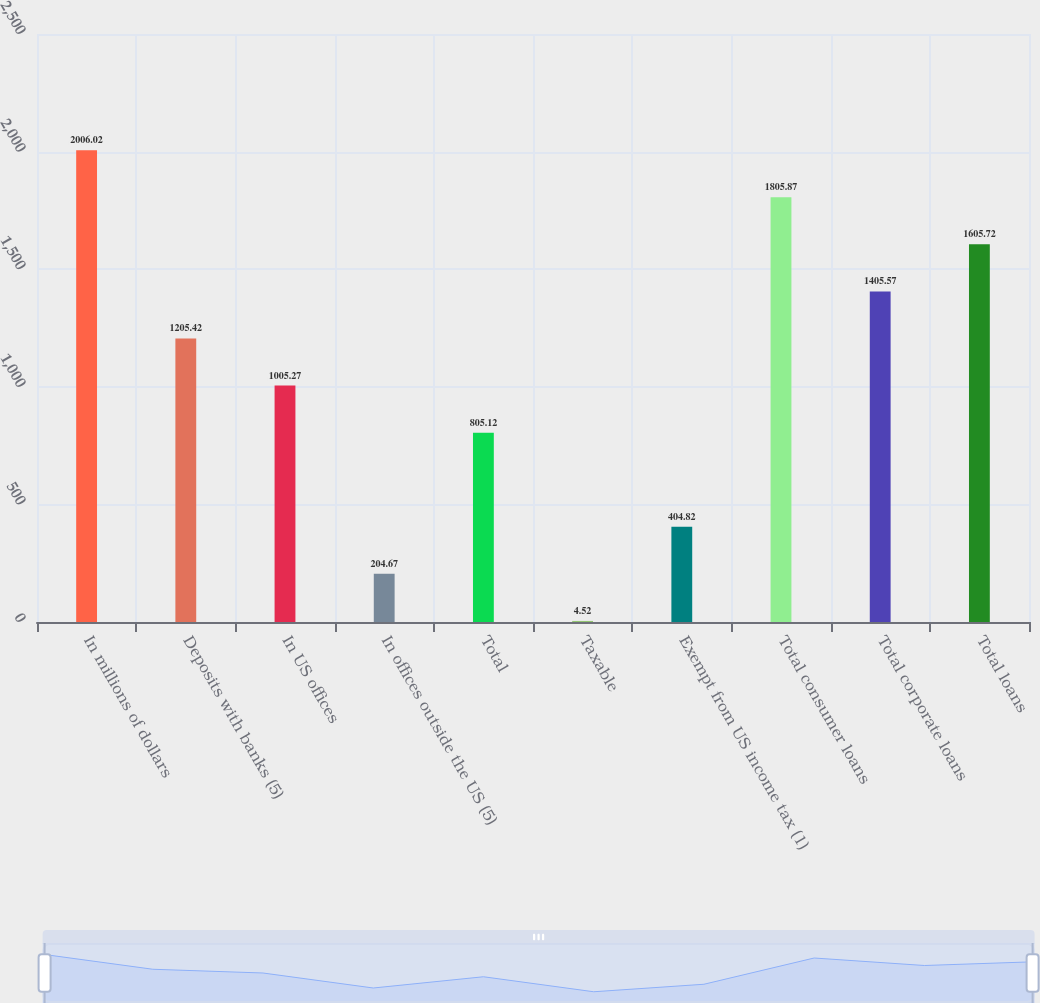Convert chart to OTSL. <chart><loc_0><loc_0><loc_500><loc_500><bar_chart><fcel>In millions of dollars<fcel>Deposits with banks (5)<fcel>In US offices<fcel>In offices outside the US (5)<fcel>Total<fcel>Taxable<fcel>Exempt from US income tax (1)<fcel>Total consumer loans<fcel>Total corporate loans<fcel>Total loans<nl><fcel>2006.02<fcel>1205.42<fcel>1005.27<fcel>204.67<fcel>805.12<fcel>4.52<fcel>404.82<fcel>1805.87<fcel>1405.57<fcel>1605.72<nl></chart> 